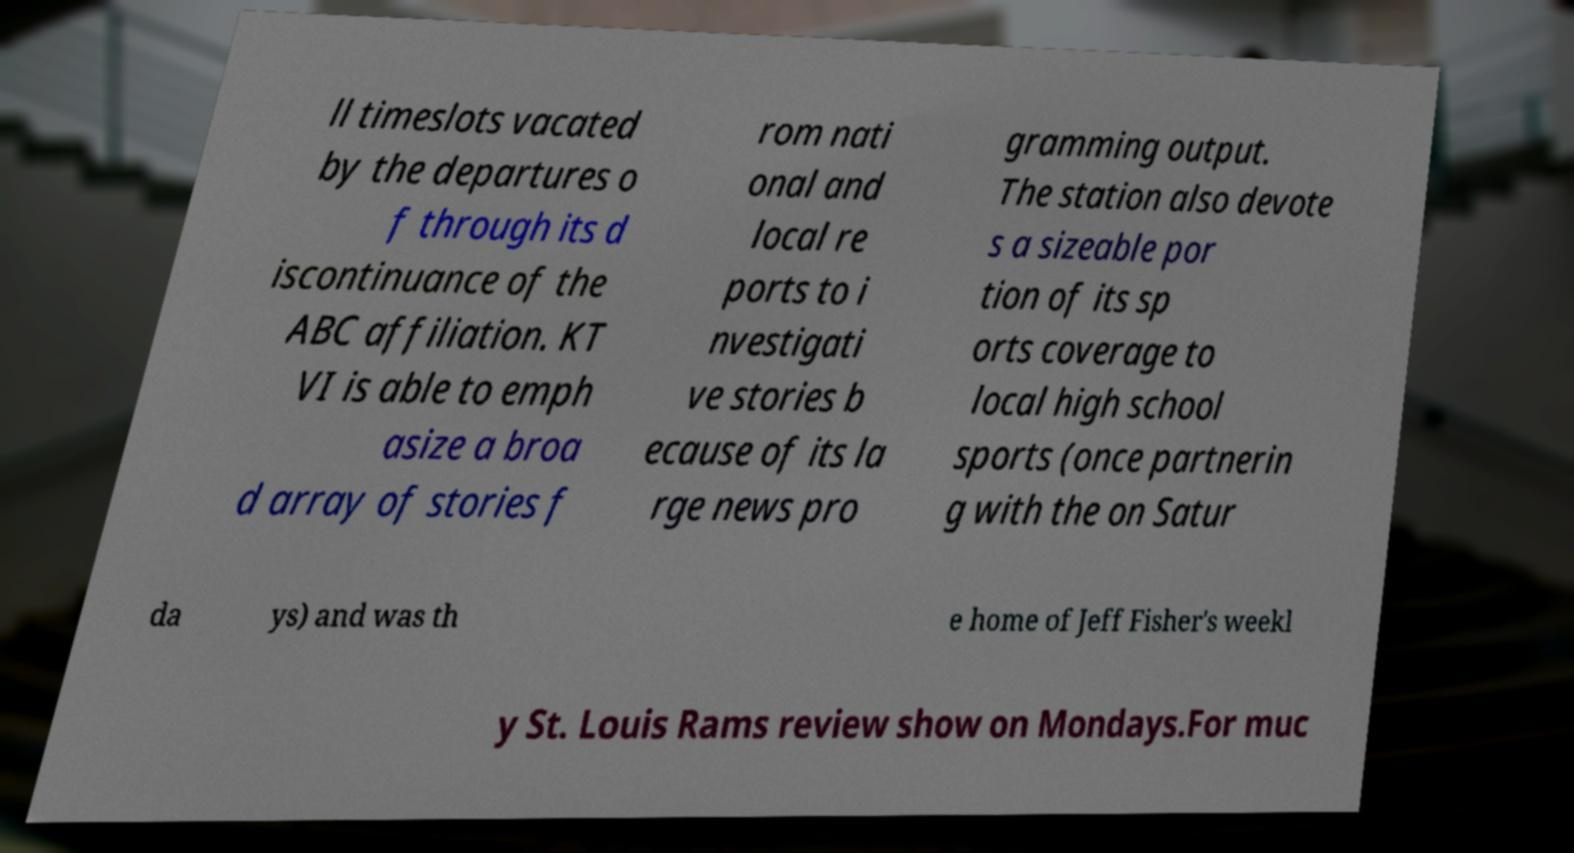Please identify and transcribe the text found in this image. ll timeslots vacated by the departures o f through its d iscontinuance of the ABC affiliation. KT VI is able to emph asize a broa d array of stories f rom nati onal and local re ports to i nvestigati ve stories b ecause of its la rge news pro gramming output. The station also devote s a sizeable por tion of its sp orts coverage to local high school sports (once partnerin g with the on Satur da ys) and was th e home of Jeff Fisher's weekl y St. Louis Rams review show on Mondays.For muc 